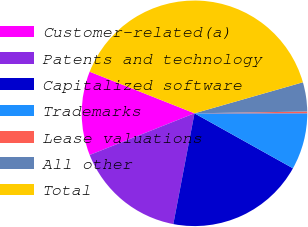Convert chart. <chart><loc_0><loc_0><loc_500><loc_500><pie_chart><fcel>Customer-related(a)<fcel>Patents and technology<fcel>Capitalized software<fcel>Trademarks<fcel>Lease valuations<fcel>All other<fcel>Total<nl><fcel>12.04%<fcel>15.97%<fcel>19.9%<fcel>8.11%<fcel>0.25%<fcel>4.18%<fcel>39.55%<nl></chart> 